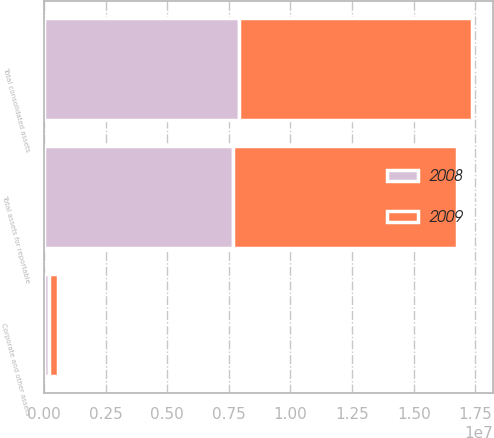<chart> <loc_0><loc_0><loc_500><loc_500><stacked_bar_chart><ecel><fcel>Total assets for reportable<fcel>Corporate and other assets<fcel>Total consolidated assets<nl><fcel>2008<fcel>7.68345e+06<fcel>223019<fcel>7.90647e+06<nl><fcel>2009<fcel>9.07413e+06<fcel>367739<fcel>9.44187e+06<nl></chart> 